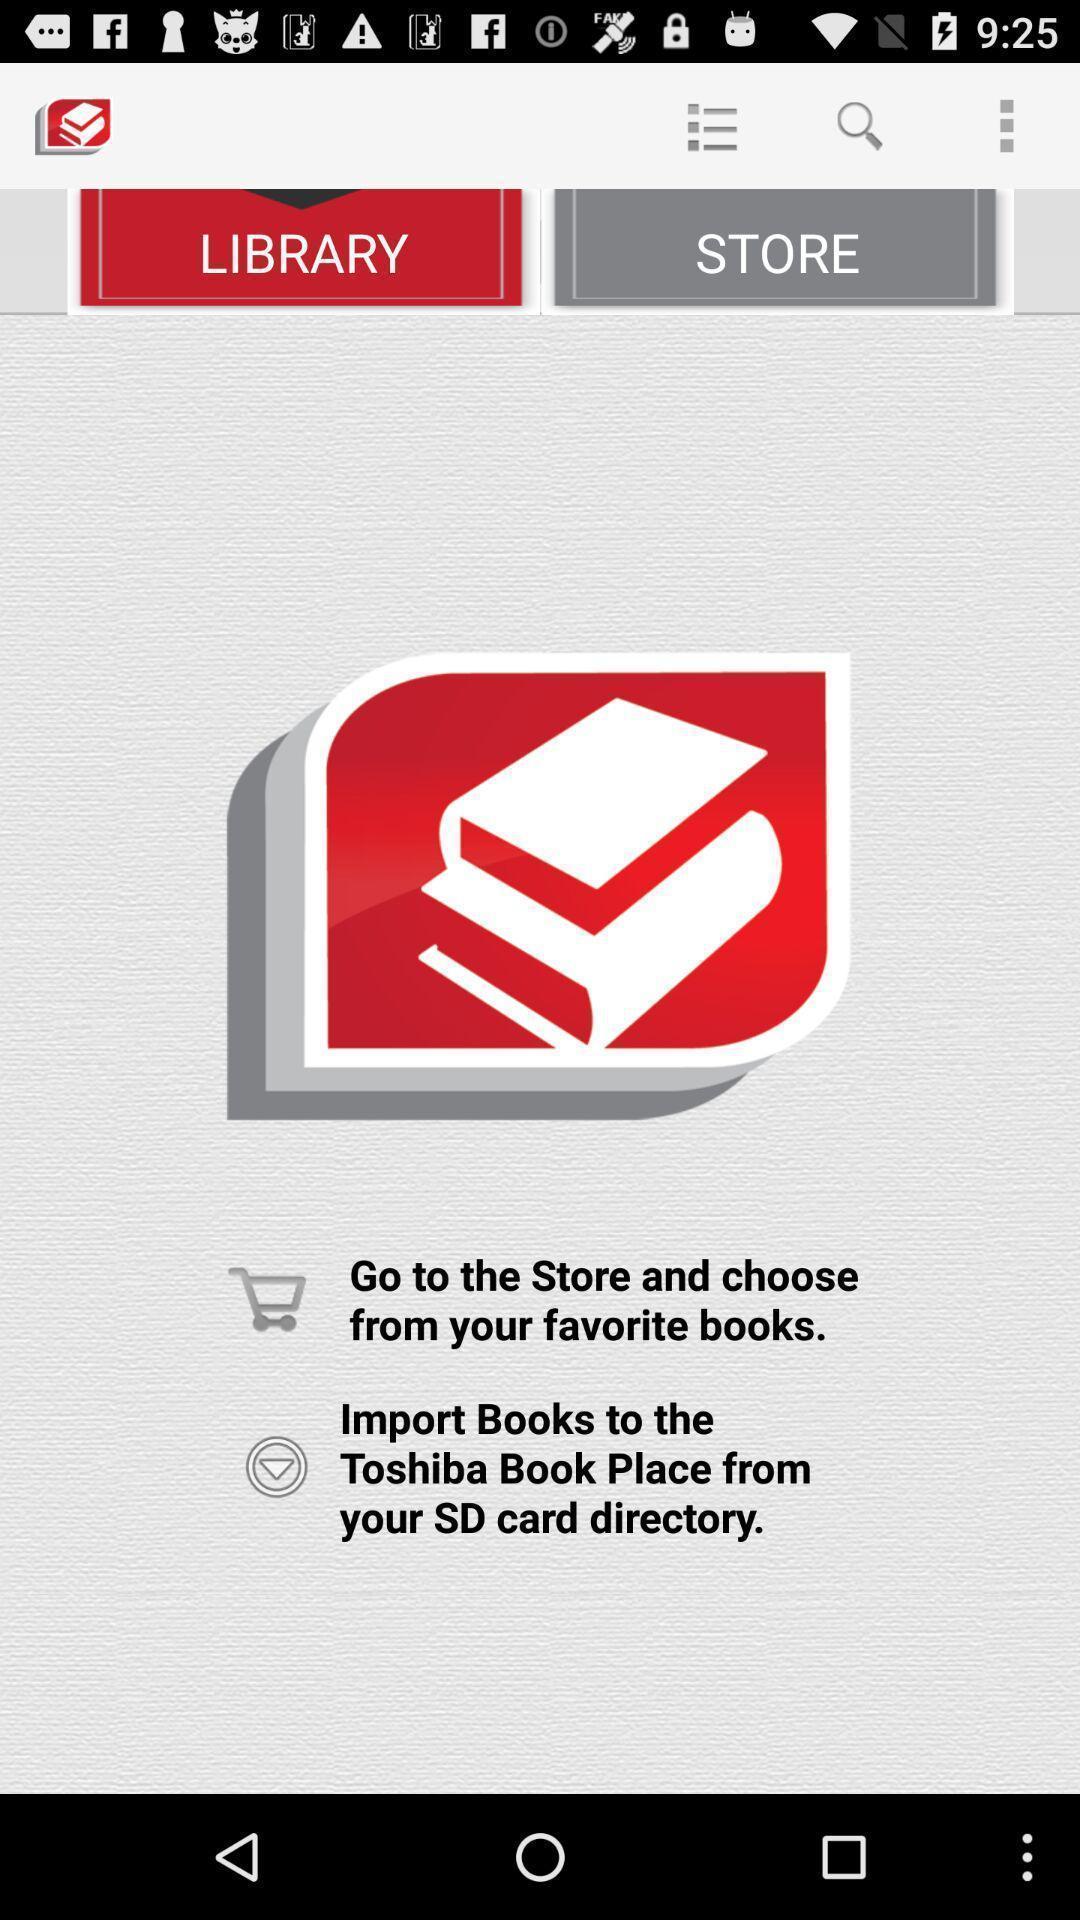Give me a narrative description of this picture. Welcome page. 